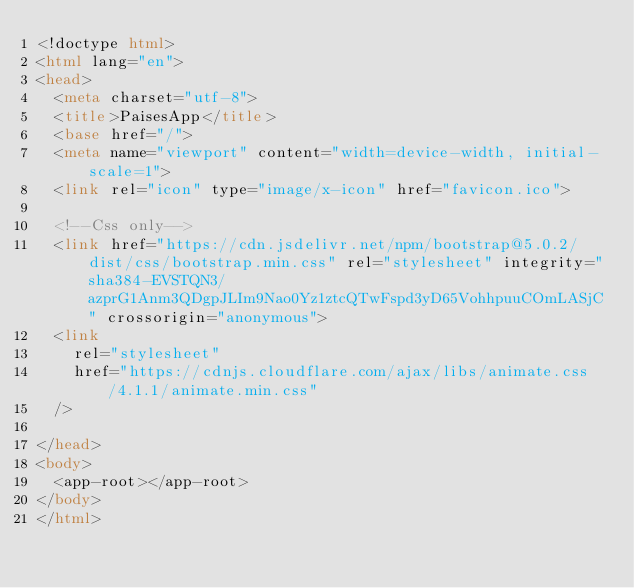Convert code to text. <code><loc_0><loc_0><loc_500><loc_500><_HTML_><!doctype html>
<html lang="en">
<head>
  <meta charset="utf-8">
  <title>PaisesApp</title>
  <base href="/">
  <meta name="viewport" content="width=device-width, initial-scale=1">
  <link rel="icon" type="image/x-icon" href="favicon.ico">
  
  <!--Css only-->
  <link href="https://cdn.jsdelivr.net/npm/bootstrap@5.0.2/dist/css/bootstrap.min.css" rel="stylesheet" integrity="sha384-EVSTQN3/azprG1Anm3QDgpJLIm9Nao0Yz1ztcQTwFspd3yD65VohhpuuCOmLASjC" crossorigin="anonymous">
  <link
    rel="stylesheet"
    href="https://cdnjs.cloudflare.com/ajax/libs/animate.css/4.1.1/animate.min.css"
  />

</head>
<body>
  <app-root></app-root>
</body>
</html>
</code> 